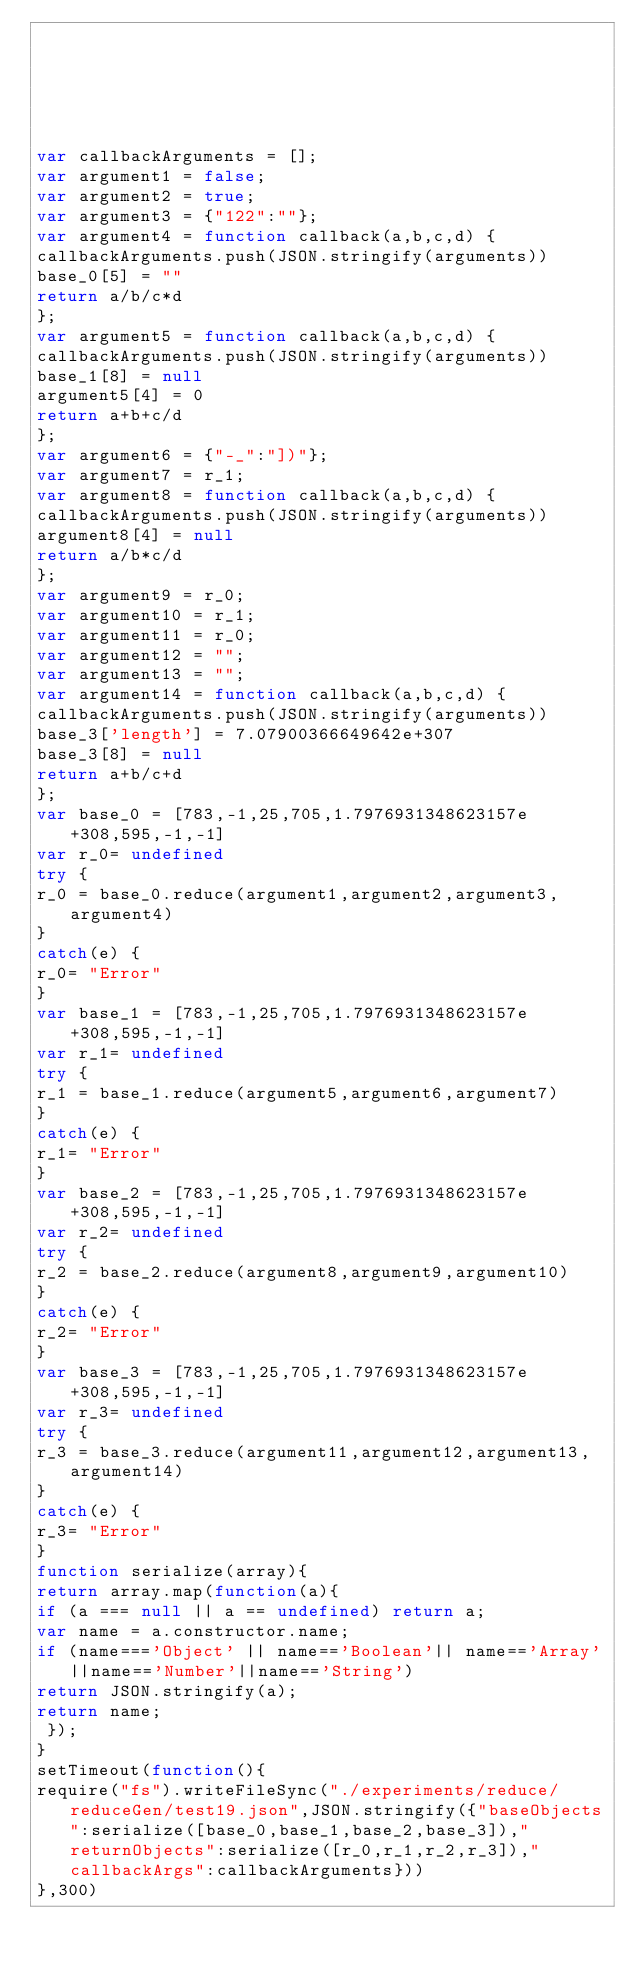Convert code to text. <code><loc_0><loc_0><loc_500><loc_500><_JavaScript_>





var callbackArguments = [];
var argument1 = false;
var argument2 = true;
var argument3 = {"122":""};
var argument4 = function callback(a,b,c,d) { 
callbackArguments.push(JSON.stringify(arguments))
base_0[5] = ""
return a/b/c*d
};
var argument5 = function callback(a,b,c,d) { 
callbackArguments.push(JSON.stringify(arguments))
base_1[8] = null
argument5[4] = 0
return a+b+c/d
};
var argument6 = {"-_":"])"};
var argument7 = r_1;
var argument8 = function callback(a,b,c,d) { 
callbackArguments.push(JSON.stringify(arguments))
argument8[4] = null
return a/b*c/d
};
var argument9 = r_0;
var argument10 = r_1;
var argument11 = r_0;
var argument12 = "";
var argument13 = "";
var argument14 = function callback(a,b,c,d) { 
callbackArguments.push(JSON.stringify(arguments))
base_3['length'] = 7.07900366649642e+307
base_3[8] = null
return a+b/c+d
};
var base_0 = [783,-1,25,705,1.7976931348623157e+308,595,-1,-1]
var r_0= undefined
try {
r_0 = base_0.reduce(argument1,argument2,argument3,argument4)
}
catch(e) {
r_0= "Error"
}
var base_1 = [783,-1,25,705,1.7976931348623157e+308,595,-1,-1]
var r_1= undefined
try {
r_1 = base_1.reduce(argument5,argument6,argument7)
}
catch(e) {
r_1= "Error"
}
var base_2 = [783,-1,25,705,1.7976931348623157e+308,595,-1,-1]
var r_2= undefined
try {
r_2 = base_2.reduce(argument8,argument9,argument10)
}
catch(e) {
r_2= "Error"
}
var base_3 = [783,-1,25,705,1.7976931348623157e+308,595,-1,-1]
var r_3= undefined
try {
r_3 = base_3.reduce(argument11,argument12,argument13,argument14)
}
catch(e) {
r_3= "Error"
}
function serialize(array){
return array.map(function(a){
if (a === null || a == undefined) return a;
var name = a.constructor.name;
if (name==='Object' || name=='Boolean'|| name=='Array'||name=='Number'||name=='String')
return JSON.stringify(a);
return name;
 });
}
setTimeout(function(){
require("fs").writeFileSync("./experiments/reduce/reduceGen/test19.json",JSON.stringify({"baseObjects":serialize([base_0,base_1,base_2,base_3]),"returnObjects":serialize([r_0,r_1,r_2,r_3]),"callbackArgs":callbackArguments}))
},300)</code> 